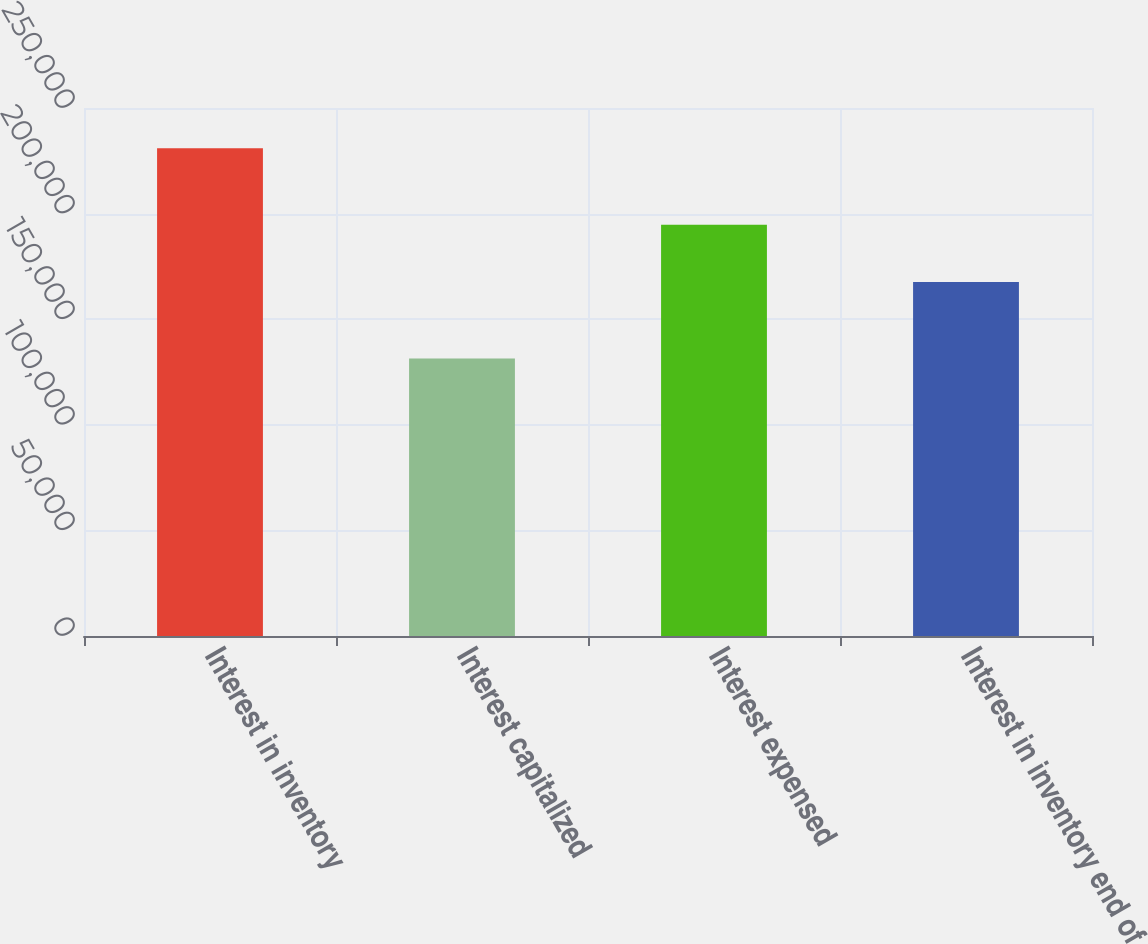Convert chart. <chart><loc_0><loc_0><loc_500><loc_500><bar_chart><fcel>Interest in inventory<fcel>Interest capitalized<fcel>Interest expensed<fcel>Interest in inventory end of<nl><fcel>230922<fcel>131444<fcel>194728<fcel>167638<nl></chart> 